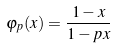<formula> <loc_0><loc_0><loc_500><loc_500>\varphi _ { p } ( x ) = \frac { 1 - x } { 1 - p x }</formula> 